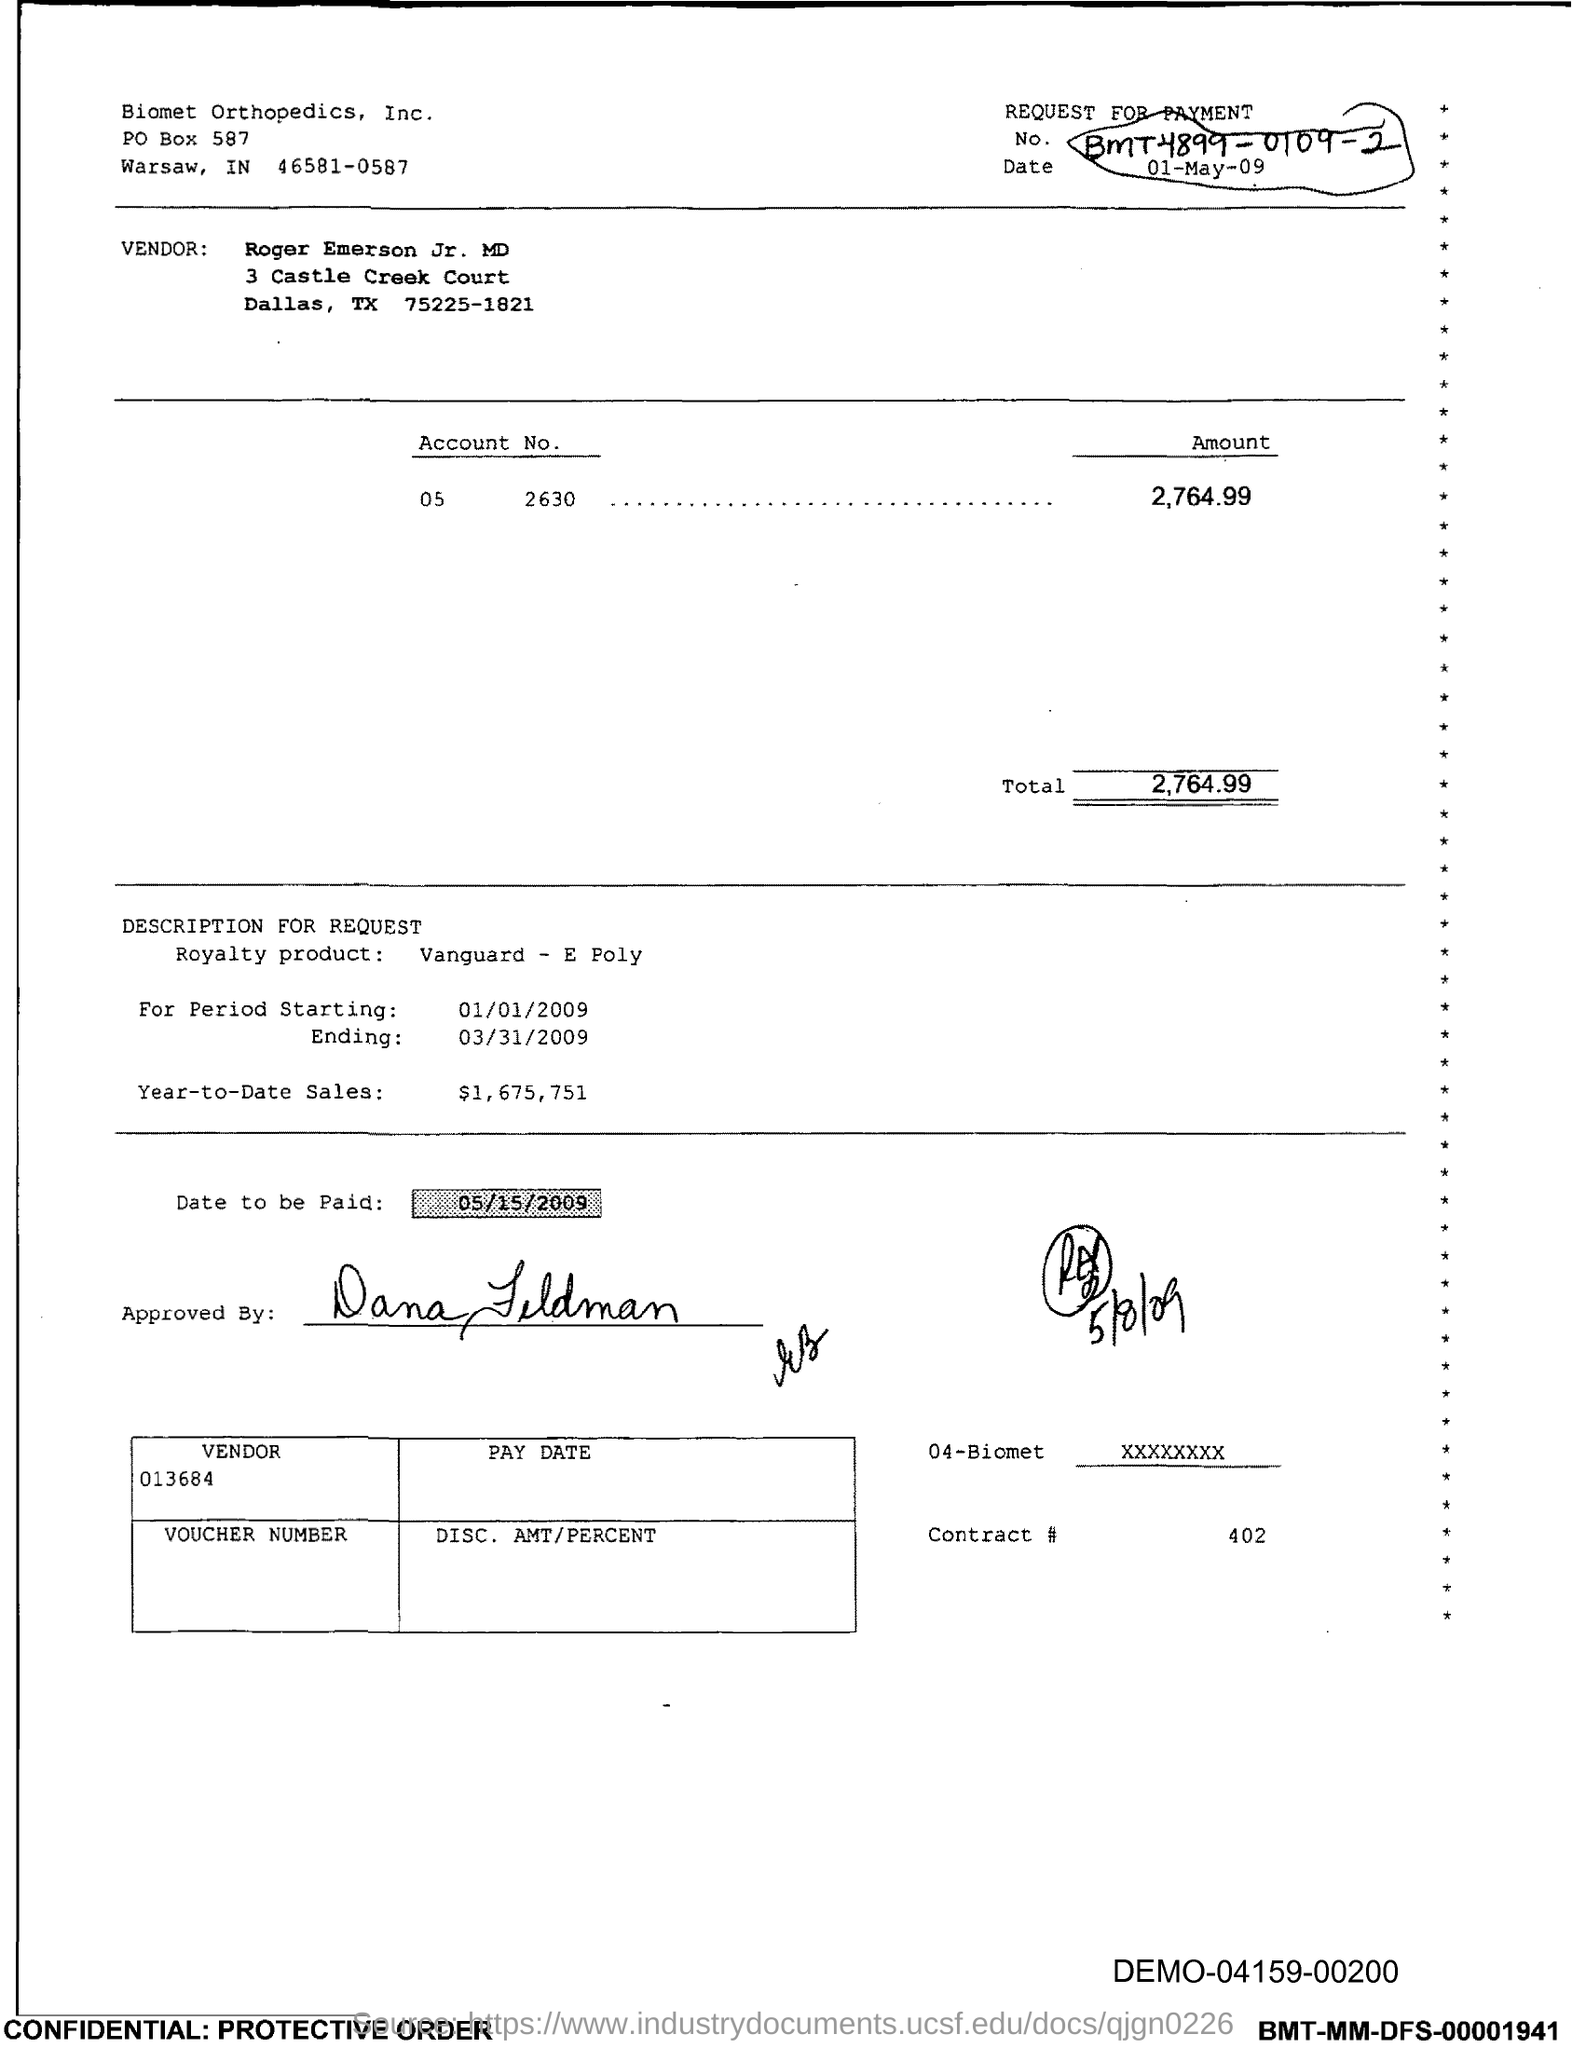What is the PO Box Number mentioned in the document?
Your answer should be compact. 587. What is the Contract # Number?
Ensure brevity in your answer.  402. What is the Total?
Your answer should be very brief. 2,764.99. 